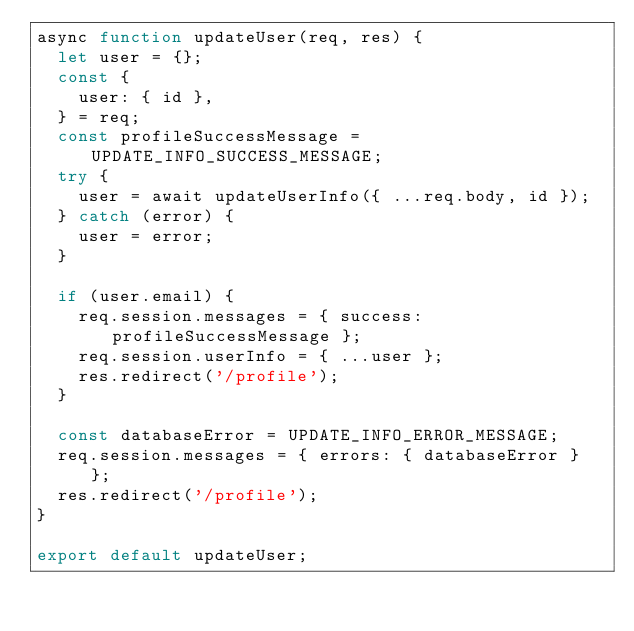<code> <loc_0><loc_0><loc_500><loc_500><_JavaScript_>async function updateUser(req, res) {
  let user = {};
  const {
    user: { id },
  } = req;
  const profileSuccessMessage = UPDATE_INFO_SUCCESS_MESSAGE;
  try {
    user = await updateUserInfo({ ...req.body, id });
  } catch (error) {
    user = error;
  }

  if (user.email) {
    req.session.messages = { success: profileSuccessMessage };
    req.session.userInfo = { ...user };
    res.redirect('/profile');
  }

  const databaseError = UPDATE_INFO_ERROR_MESSAGE;
  req.session.messages = { errors: { databaseError } };
  res.redirect('/profile');
}

export default updateUser;
</code> 